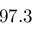Convert formula to latex. <formula><loc_0><loc_0><loc_500><loc_500>9 7 . 3</formula> 